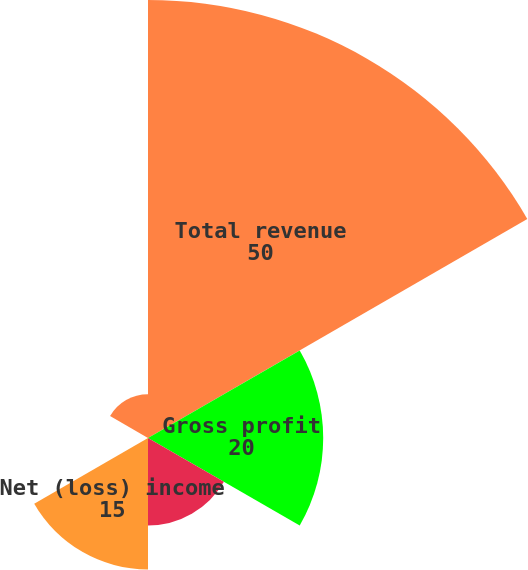Convert chart. <chart><loc_0><loc_0><loc_500><loc_500><pie_chart><fcel>Total revenue<fcel>Gross profit<fcel>Income before cumulative<fcel>Net (loss) income<fcel>Diluted income before<fcel>Diluted net (loss) income per<nl><fcel>50.0%<fcel>20.0%<fcel>10.0%<fcel>15.0%<fcel>0.0%<fcel>5.0%<nl></chart> 